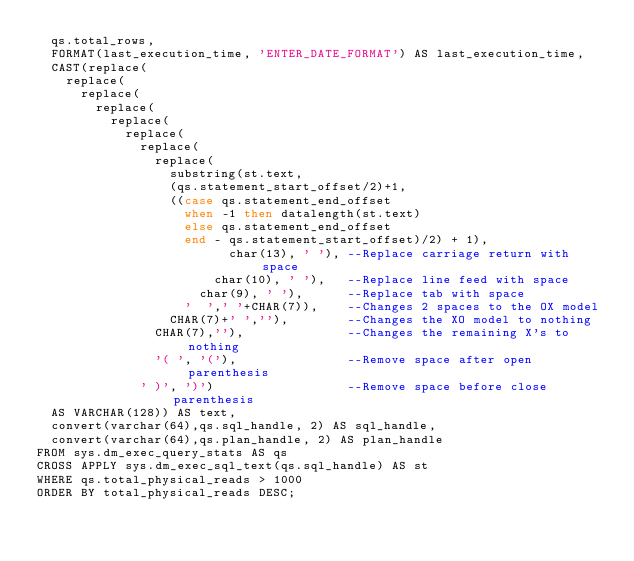Convert code to text. <code><loc_0><loc_0><loc_500><loc_500><_SQL_>  qs.total_rows,
  FORMAT(last_execution_time, 'ENTER_DATE_FORMAT') AS last_execution_time, 
  CAST(replace(
    replace(
      replace(
        replace(
          replace(
            replace(
              replace(
                replace(
                  substring(st.text, 
                  (qs.statement_start_offset/2)+1, 
                  ((case qs.statement_end_offset
                    when -1 then datalength(st.text)
                    else qs.statement_end_offset
                    end - qs.statement_start_offset)/2) + 1),
                          char(13), ' '), --Replace carriage return with space
                        char(10), ' '),   --Replace line feed with space
                      char(9), ' '),      --Replace tab with space
                    '  ',' '+CHAR(7)),    --Changes 2 spaces to the OX model
                  CHAR(7)+' ',''),        --Changes the XO model to nothing
                CHAR(7),''),              --Changes the remaining X's to nothing
                '( ', '('),               --Remove space after open parenthesis
              ' )', ')')                  --Remove space before close parenthesis
  AS VARCHAR(128)) AS text,
  convert(varchar(64),qs.sql_handle, 2) AS sql_handle,
  convert(varchar(64),qs.plan_handle, 2) AS plan_handle
FROM sys.dm_exec_query_stats AS qs
CROSS APPLY sys.dm_exec_sql_text(qs.sql_handle) AS st
WHERE qs.total_physical_reads > 1000
ORDER BY total_physical_reads DESC;
</code> 